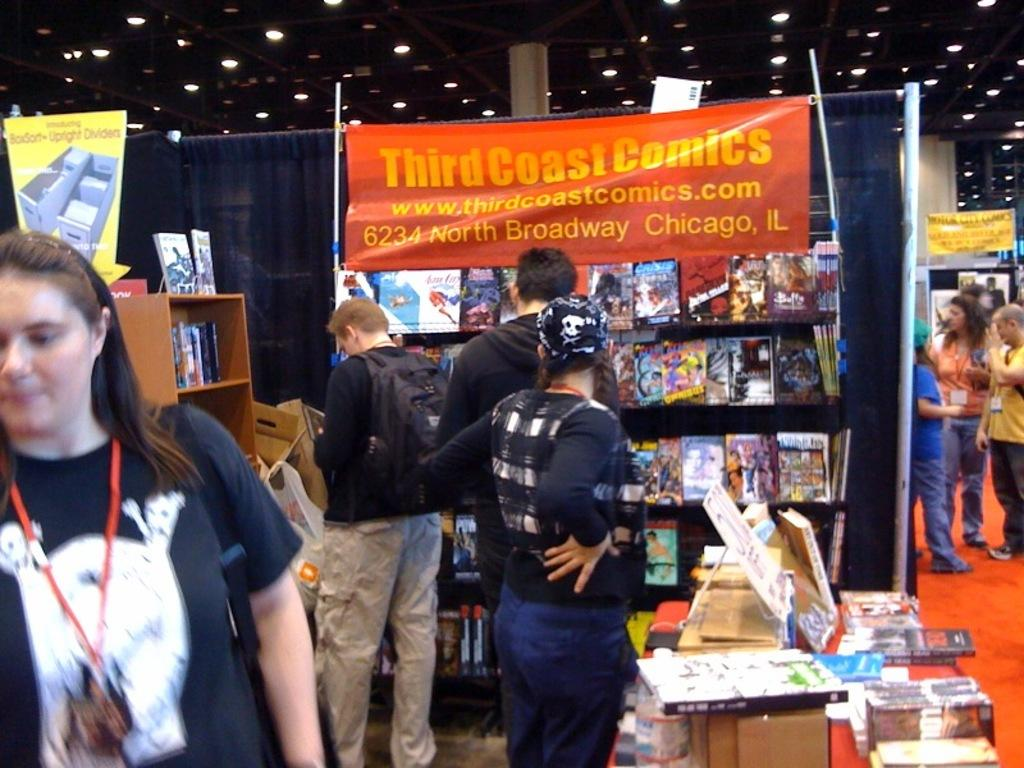<image>
Render a clear and concise summary of the photo. People look through displays of Third Coast Comics. 